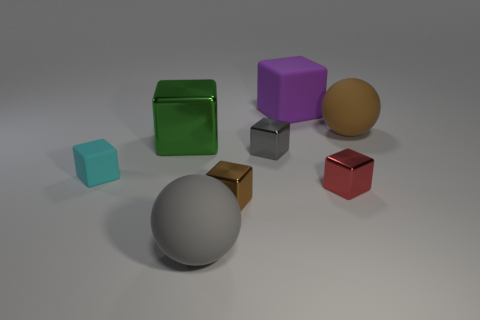Is there any other thing that is the same color as the large matte block?
Provide a short and direct response. No. There is a gray cube that is made of the same material as the green block; what is its size?
Offer a terse response. Small. What material is the cyan thing?
Your answer should be very brief. Rubber. How many brown cylinders are the same size as the cyan thing?
Give a very brief answer. 0. Are there any big metallic objects of the same shape as the small gray metal thing?
Your answer should be compact. Yes. What is the color of the shiny object that is the same size as the purple rubber thing?
Make the answer very short. Green. There is a rubber ball in front of the brown thing behind the green thing; what color is it?
Keep it short and to the point. Gray. Do the matte thing right of the small red block and the small matte object have the same color?
Give a very brief answer. No. There is a metallic thing that is on the right side of the large block that is behind the matte sphere that is to the right of the large gray ball; what shape is it?
Provide a succinct answer. Cube. There is a shiny cube that is behind the gray metal block; what number of red cubes are to the left of it?
Your response must be concise. 0. 